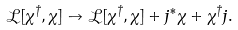Convert formula to latex. <formula><loc_0><loc_0><loc_500><loc_500>\mathcal { L } [ \chi ^ { \dagger } , \chi ] \to \mathcal { L } [ \chi ^ { \dagger } , \chi ] + j ^ { \ast } \chi + \chi ^ { \dagger } j .</formula> 